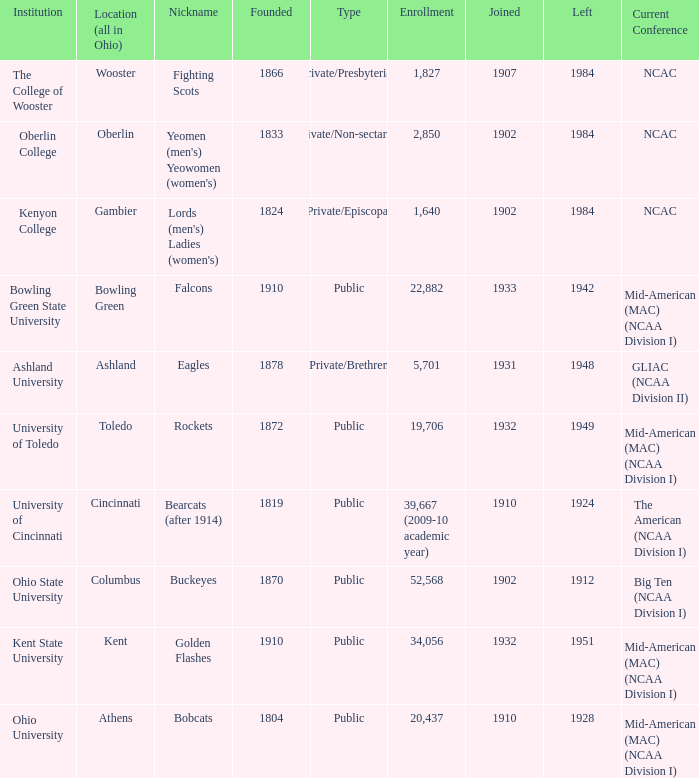Which year did enrolled Gambier members leave? 1984.0. Could you parse the entire table? {'header': ['Institution', 'Location (all in Ohio)', 'Nickname', 'Founded', 'Type', 'Enrollment', 'Joined', 'Left', 'Current Conference'], 'rows': [['The College of Wooster', 'Wooster', 'Fighting Scots', '1866', 'Private/Presbyterian', '1,827', '1907', '1984', 'NCAC'], ['Oberlin College', 'Oberlin', "Yeomen (men's) Yeowomen (women's)", '1833', 'Private/Non-sectarian', '2,850', '1902', '1984', 'NCAC'], ['Kenyon College', 'Gambier', "Lords (men's) Ladies (women's)", '1824', 'Private/Episcopal', '1,640', '1902', '1984', 'NCAC'], ['Bowling Green State University', 'Bowling Green', 'Falcons', '1910', 'Public', '22,882', '1933', '1942', 'Mid-American (MAC) (NCAA Division I)'], ['Ashland University', 'Ashland', 'Eagles', '1878', 'Private/Brethren', '5,701', '1931', '1948', 'GLIAC (NCAA Division II)'], ['University of Toledo', 'Toledo', 'Rockets', '1872', 'Public', '19,706', '1932', '1949', 'Mid-American (MAC) (NCAA Division I)'], ['University of Cincinnati', 'Cincinnati', 'Bearcats (after 1914)', '1819', 'Public', '39,667 (2009-10 academic year)', '1910', '1924', 'The American (NCAA Division I)'], ['Ohio State University', 'Columbus', 'Buckeyes', '1870', 'Public', '52,568', '1902', '1912', 'Big Ten (NCAA Division I)'], ['Kent State University', 'Kent', 'Golden Flashes', '1910', 'Public', '34,056', '1932', '1951', 'Mid-American (MAC) (NCAA Division I)'], ['Ohio University', 'Athens', 'Bobcats', '1804', 'Public', '20,437', '1910', '1928', 'Mid-American (MAC) (NCAA Division I)']]} 